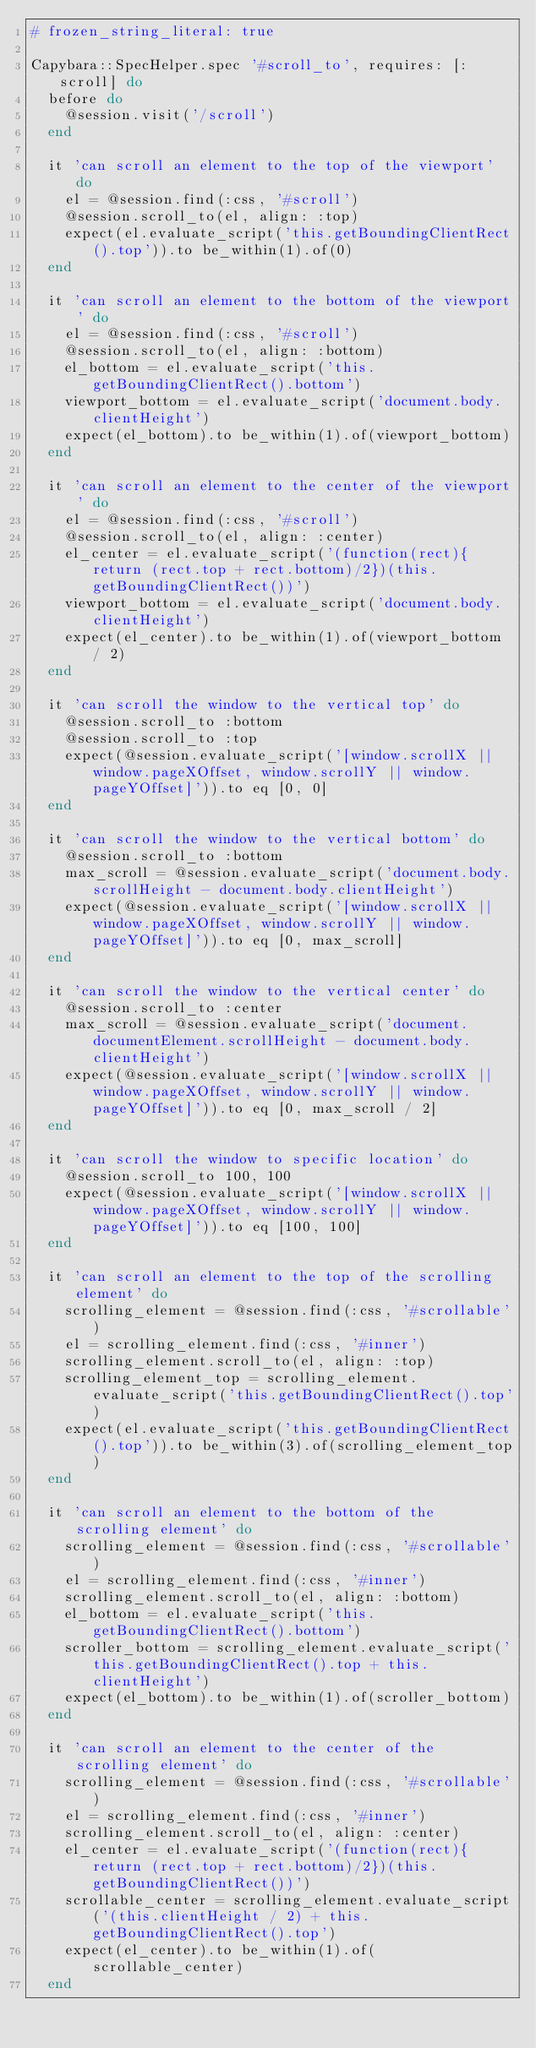Convert code to text. <code><loc_0><loc_0><loc_500><loc_500><_Ruby_># frozen_string_literal: true

Capybara::SpecHelper.spec '#scroll_to', requires: [:scroll] do
  before do
    @session.visit('/scroll')
  end

  it 'can scroll an element to the top of the viewport' do
    el = @session.find(:css, '#scroll')
    @session.scroll_to(el, align: :top)
    expect(el.evaluate_script('this.getBoundingClientRect().top')).to be_within(1).of(0)
  end

  it 'can scroll an element to the bottom of the viewport' do
    el = @session.find(:css, '#scroll')
    @session.scroll_to(el, align: :bottom)
    el_bottom = el.evaluate_script('this.getBoundingClientRect().bottom')
    viewport_bottom = el.evaluate_script('document.body.clientHeight')
    expect(el_bottom).to be_within(1).of(viewport_bottom)
  end

  it 'can scroll an element to the center of the viewport' do
    el = @session.find(:css, '#scroll')
    @session.scroll_to(el, align: :center)
    el_center = el.evaluate_script('(function(rect){return (rect.top + rect.bottom)/2})(this.getBoundingClientRect())')
    viewport_bottom = el.evaluate_script('document.body.clientHeight')
    expect(el_center).to be_within(1).of(viewport_bottom / 2)
  end

  it 'can scroll the window to the vertical top' do
    @session.scroll_to :bottom
    @session.scroll_to :top
    expect(@session.evaluate_script('[window.scrollX || window.pageXOffset, window.scrollY || window.pageYOffset]')).to eq [0, 0]
  end

  it 'can scroll the window to the vertical bottom' do
    @session.scroll_to :bottom
    max_scroll = @session.evaluate_script('document.body.scrollHeight - document.body.clientHeight')
    expect(@session.evaluate_script('[window.scrollX || window.pageXOffset, window.scrollY || window.pageYOffset]')).to eq [0, max_scroll]
  end

  it 'can scroll the window to the vertical center' do
    @session.scroll_to :center
    max_scroll = @session.evaluate_script('document.documentElement.scrollHeight - document.body.clientHeight')
    expect(@session.evaluate_script('[window.scrollX || window.pageXOffset, window.scrollY || window.pageYOffset]')).to eq [0, max_scroll / 2]
  end

  it 'can scroll the window to specific location' do
    @session.scroll_to 100, 100
    expect(@session.evaluate_script('[window.scrollX || window.pageXOffset, window.scrollY || window.pageYOffset]')).to eq [100, 100]
  end

  it 'can scroll an element to the top of the scrolling element' do
    scrolling_element = @session.find(:css, '#scrollable')
    el = scrolling_element.find(:css, '#inner')
    scrolling_element.scroll_to(el, align: :top)
    scrolling_element_top = scrolling_element.evaluate_script('this.getBoundingClientRect().top')
    expect(el.evaluate_script('this.getBoundingClientRect().top')).to be_within(3).of(scrolling_element_top)
  end

  it 'can scroll an element to the bottom of the scrolling element' do
    scrolling_element = @session.find(:css, '#scrollable')
    el = scrolling_element.find(:css, '#inner')
    scrolling_element.scroll_to(el, align: :bottom)
    el_bottom = el.evaluate_script('this.getBoundingClientRect().bottom')
    scroller_bottom = scrolling_element.evaluate_script('this.getBoundingClientRect().top + this.clientHeight')
    expect(el_bottom).to be_within(1).of(scroller_bottom)
  end

  it 'can scroll an element to the center of the scrolling element' do
    scrolling_element = @session.find(:css, '#scrollable')
    el = scrolling_element.find(:css, '#inner')
    scrolling_element.scroll_to(el, align: :center)
    el_center = el.evaluate_script('(function(rect){return (rect.top + rect.bottom)/2})(this.getBoundingClientRect())')
    scrollable_center = scrolling_element.evaluate_script('(this.clientHeight / 2) + this.getBoundingClientRect().top')
    expect(el_center).to be_within(1).of(scrollable_center)
  end
</code> 